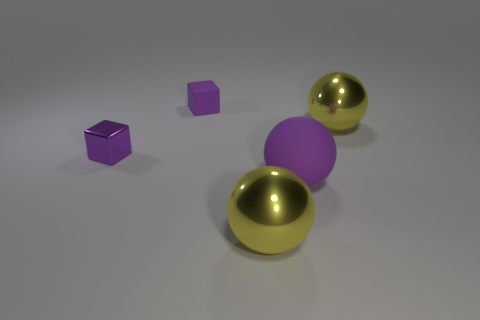How many other balls are the same size as the purple matte sphere?
Provide a succinct answer. 2. There is another tiny thing that is the same color as the tiny shiny object; what shape is it?
Ensure brevity in your answer.  Cube. There is a small purple metal cube to the left of the big purple matte ball; is there a shiny sphere that is behind it?
Give a very brief answer. Yes. What number of things are either big objects that are behind the tiny purple metal cube or rubber blocks?
Your answer should be compact. 2. How many yellow spheres are there?
Make the answer very short. 2. There is a small object that is made of the same material as the large purple sphere; what is its shape?
Make the answer very short. Cube. What size is the thing that is to the left of the small purple object right of the tiny metal cube?
Provide a succinct answer. Small. What number of objects are either objects that are to the left of the purple sphere or matte objects right of the small matte block?
Give a very brief answer. 4. Are there fewer large purple things than cyan objects?
Give a very brief answer. No. How many things are tiny purple blocks or big yellow shiny balls?
Provide a succinct answer. 4. 